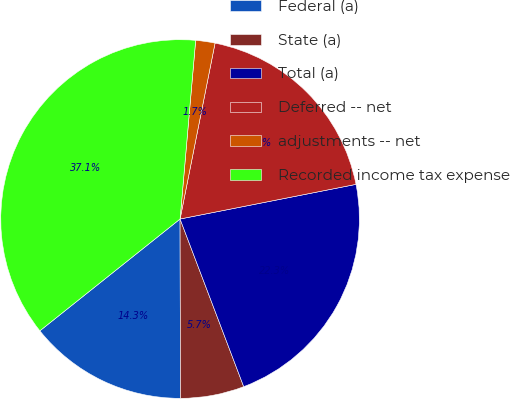Convert chart to OTSL. <chart><loc_0><loc_0><loc_500><loc_500><pie_chart><fcel>Federal (a)<fcel>State (a)<fcel>Total (a)<fcel>Deferred -- net<fcel>adjustments -- net<fcel>Recorded income tax expense<nl><fcel>14.32%<fcel>5.74%<fcel>22.32%<fcel>18.78%<fcel>1.74%<fcel>37.1%<nl></chart> 